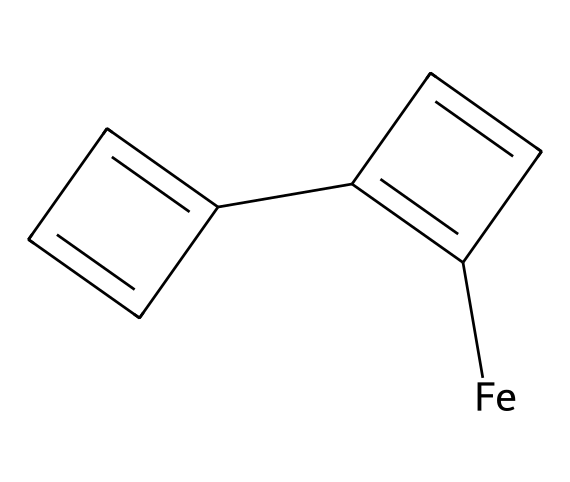What is the central metal atom in ferrocene? The chemical structure shows an iron atom, represented by [Fe], at the center of the structure, bonded to two cyclopentadienyl anions (the ring structures).
Answer: iron How many carbon atoms are present in ferrocene? By analyzing the structure, there are ten carbon atoms in total: five from each of the two cyclopentadienyl rings.
Answer: ten What type of chemical bonding occurs between iron and the cyclic rings? The bonding between iron and the cyclopentadienyl rings is characterized as coordinate covalent bonding, where each ring donates electron density to the iron atom.
Answer: coordinate covalent How many double bonds are present in the ferrocene structure? There are four double bonds present within the two cyclopentadienyl rings, evidenced by the alternating double bonds in each ring.
Answer: four What is the structural formula type of ferrocene? The structure shows it belongs to the category of metallocenes, which are organometallic compounds comprising a metal sandwiched between two cyclopentadienyl anions.
Answer: metallocene What kind of symmetry is exhibited by the structure of ferrocene? The structure exhibits D5h symmetry due to the arrangement of the two identical cyclopentadienyl rings around the central iron atom in a symmetric fashion.
Answer: D5h Why is ferrocene considered an important organometallic compound in electronics? Ferrocene's stable structure and electronic properties allow it to be used as a charge carrier and in early computer memory devices, enhancing performance.
Answer: electronics 